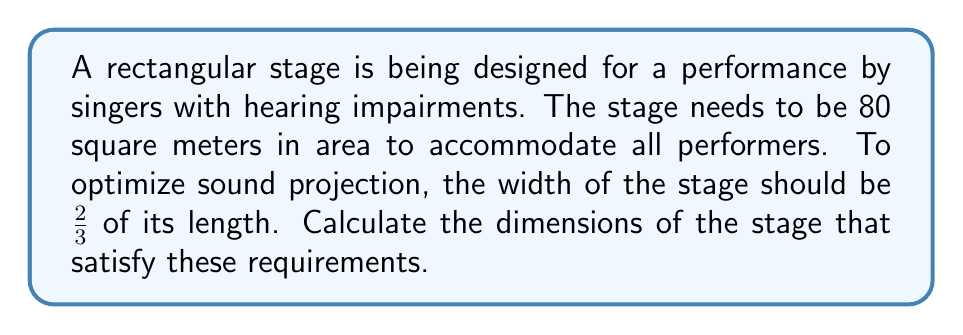What is the answer to this math problem? Let's approach this step-by-step:

1) Let the length of the stage be $l$ and the width be $w$.

2) Given that the area of the stage is 80 square meters:

   $$A = l \times w = 80$$

3) We're told that the width should be 2/3 of the length:

   $$w = \frac{2}{3}l$$

4) Substituting this into the area equation:

   $$l \times \frac{2}{3}l = 80$$

5) Simplify:

   $$\frac{2}{3}l^2 = 80$$

6) Multiply both sides by 3/2:

   $$l^2 = 80 \times \frac{3}{2} = 120$$

7) Take the square root of both sides:

   $$l = \sqrt{120} = 2\sqrt{30} \approx 10.95$$

8) Now that we have the length, we can calculate the width:

   $$w = \frac{2}{3}l = \frac{2}{3} \times 2\sqrt{30} = \frac{4\sqrt{30}}{3} \approx 7.30$$

Therefore, the stage should be approximately 10.95 meters long and 7.30 meters wide.

[asy]
size(200);
draw((0,0)--(10.95,0)--(10.95,7.3)--(0,7.3)--cycle);
label("10.95 m", (5.475,0), S);
label("7.30 m", (0,3.65), W);
label("Stage", (5.475,3.65));
[/asy]
Answer: $l = 2\sqrt{30}$ m, $w = \frac{4\sqrt{30}}{3}$ m 